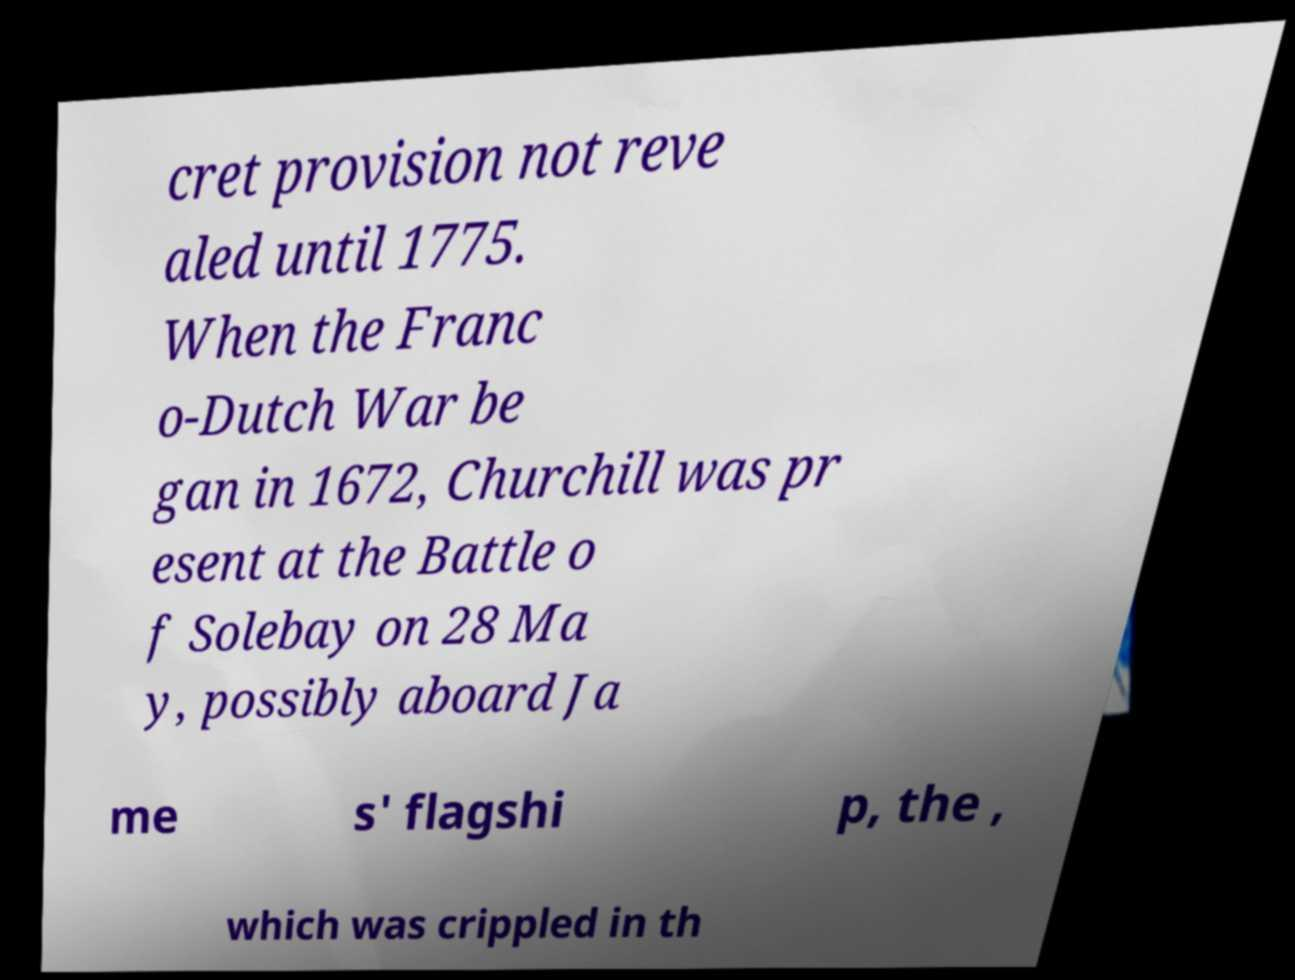I need the written content from this picture converted into text. Can you do that? cret provision not reve aled until 1775. When the Franc o-Dutch War be gan in 1672, Churchill was pr esent at the Battle o f Solebay on 28 Ma y, possibly aboard Ja me s' flagshi p, the , which was crippled in th 